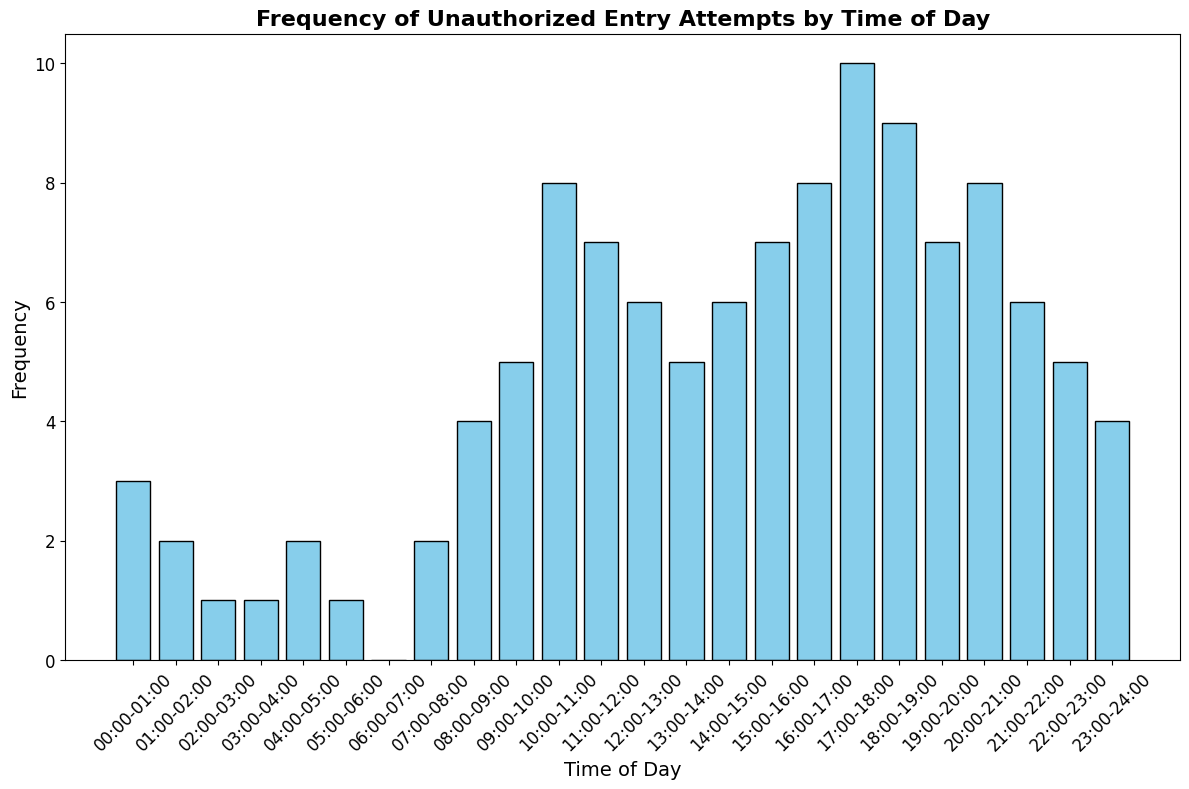What is the time range with the highest frequency of unauthorized entry attempts? To find the time range with the highest frequency, look at the bars and identify the one with the greatest height. The time range 17:00-18:00 has the highest frequency with a value of 10.
Answer: 17:00-18:00 What is the total number of unauthorized entry attempts from 10:00 to 12:00 (inclusive)? Sum the frequencies from the times 10:00-11:00, 11:00-12:00, and 12:00-13:00. The frequencies are 8, 7, and 6 respectively, so the total is 8 + 7 + 6 = 21.
Answer: 21 During which time period are unauthorized entry attempts the least frequent? Look at the bar heights to identify the lowest value. The time period 06:00-07:00 has the lowest frequency with 0 unauthorized entry attempts.
Answer: 06:00-07:00 How does the frequency of unauthorized entry attempts during the night (00:00-06:00) compare to the frequency during the evening (18:00-24:00)? Sum the frequencies for each period. For 00:00-06:00: 3 + 2 + 1 + 1 + 2 + 1 = 10. For 18:00-24:00: 9 + 7 + 8 + 6 + 5 + 4 = 39. The evening has a much higher frequency.
Answer: Evening has higher frequency What is the average frequency of unauthorized entry attempts between 12:00 and 18:00? Add the frequencies from 12:00-13:00 to 17:00-18:00 and divide by the number of time slots. (6 + 5 + 6 + 7 + 8 + 10) / 6 = 42 / 6 = 7.
Answer: 7 Which two consecutive time periods together have the highest combined frequency of unauthorized entry attempts? Compare the sum of frequencies for all consecutive time periods. 17:00-18:00 (10) and 18:00-19:00 (9) together have the highest combined frequency of 19.
Answer: 17:00-19:00 Between 08:00-10:00 and 20:00-22:00, which period has greater unauthorized entry attempts? Sum the frequencies for each period. For 08:00-10:00: 4 + 5 = 9. For 20:00-22:00: 8 + 6 = 14. The period 20:00-22:00 has a greater number of attempts.
Answer: 20:00-22:00 Which color is used to represent the bars in the histogram? The visual attribute of the bars is specified by their color; all bars are colored sky blue.
Answer: Sky blue How does the frequency of unauthorized entry attempts vary during daytime hours (08:00-20:00)? Observe the frequency values for each hour from 08:00 to 20:00. They generally increase from 08:00 (4) to a peak at 17:00 (10) and slightly decline until 19:00 (7).
Answer: Generally increases then slightly declines 